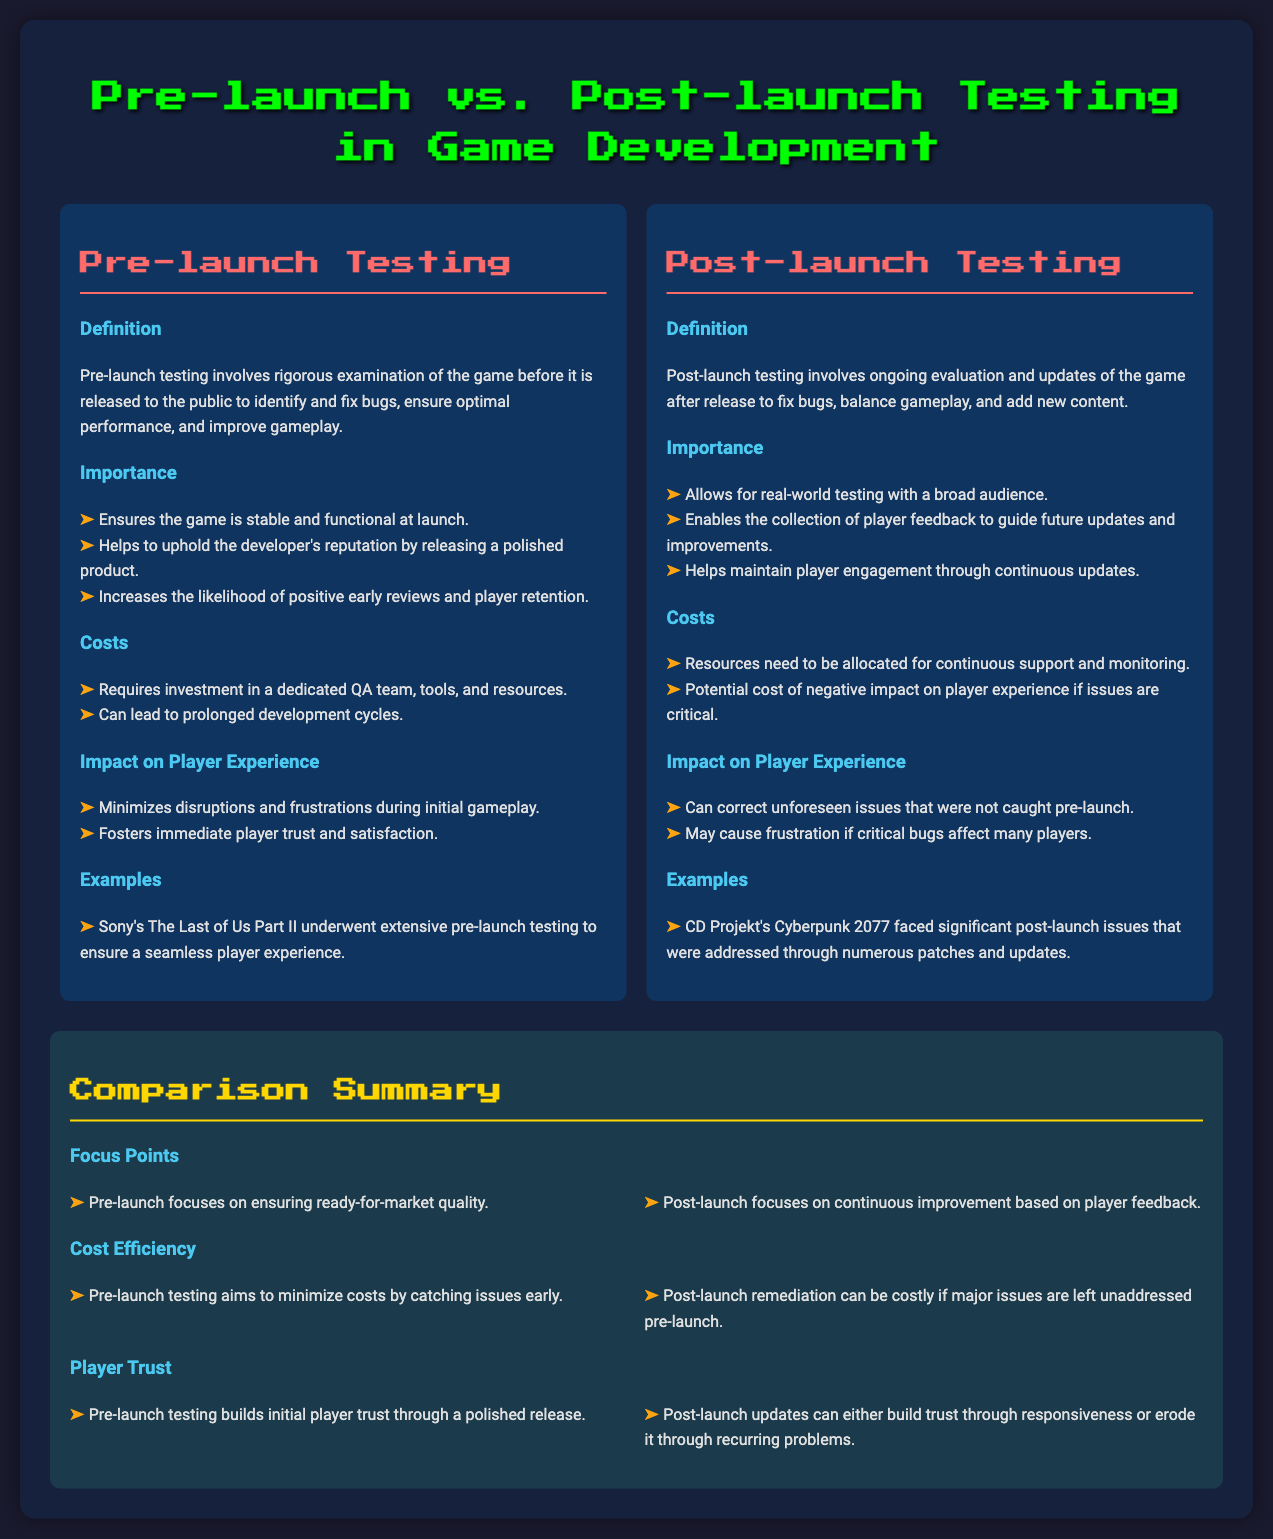What is pre-launch testing? Pre-launch testing involves rigorous examination of the game before it is released to the public to identify and fix bugs, ensure optimal performance, and improve gameplay.
Answer: Rigorous examination before release What is the primary importance of post-launch testing? Post-launch testing allows for real-world testing with a broad audience and enables the collection of player feedback to guide future updates and improvements.
Answer: Real-world testing What are the costs associated with pre-launch testing? Pre-launch testing requires investment in a dedicated QA team, tools, and resources and can lead to prolonged development cycles.
Answer: Investment and prolonged cycles What is one impact of pre-launch testing on player experience? Pre-launch testing minimizes disruptions and frustrations during initial gameplay, fostering immediate player trust and satisfaction.
Answer: Minimizes disruptions How does pre-launch testing affect player trust? Pre-launch testing builds initial player trust through a polished release.
Answer: Builds initial player trust What happens if major issues are left unaddressed pre-launch? Post-launch remediation can be costly if major issues are left unaddressed pre-launch.
Answer: Costly remediation What is an example of a game that underwent extensive pre-launch testing? An example provided is Sony's The Last of Us Part II, which underwent extensive pre-launch testing.
Answer: The Last of Us Part II What is one example of a game that faced significant post-launch issues? The example given is CD Projekt's Cyberpunk 2077, which faced significant post-launch issues addressed through numerous patches and updates.
Answer: Cyberpunk 2077 What is a key focus point of pre-launch testing? Pre-launch focuses on ensuring ready-for-market quality.
Answer: Ensuring ready-for-market quality What effect does post-launch testing have on player engagement? Post-launch testing helps maintain player engagement through continuous updates.
Answer: Maintains player engagement 